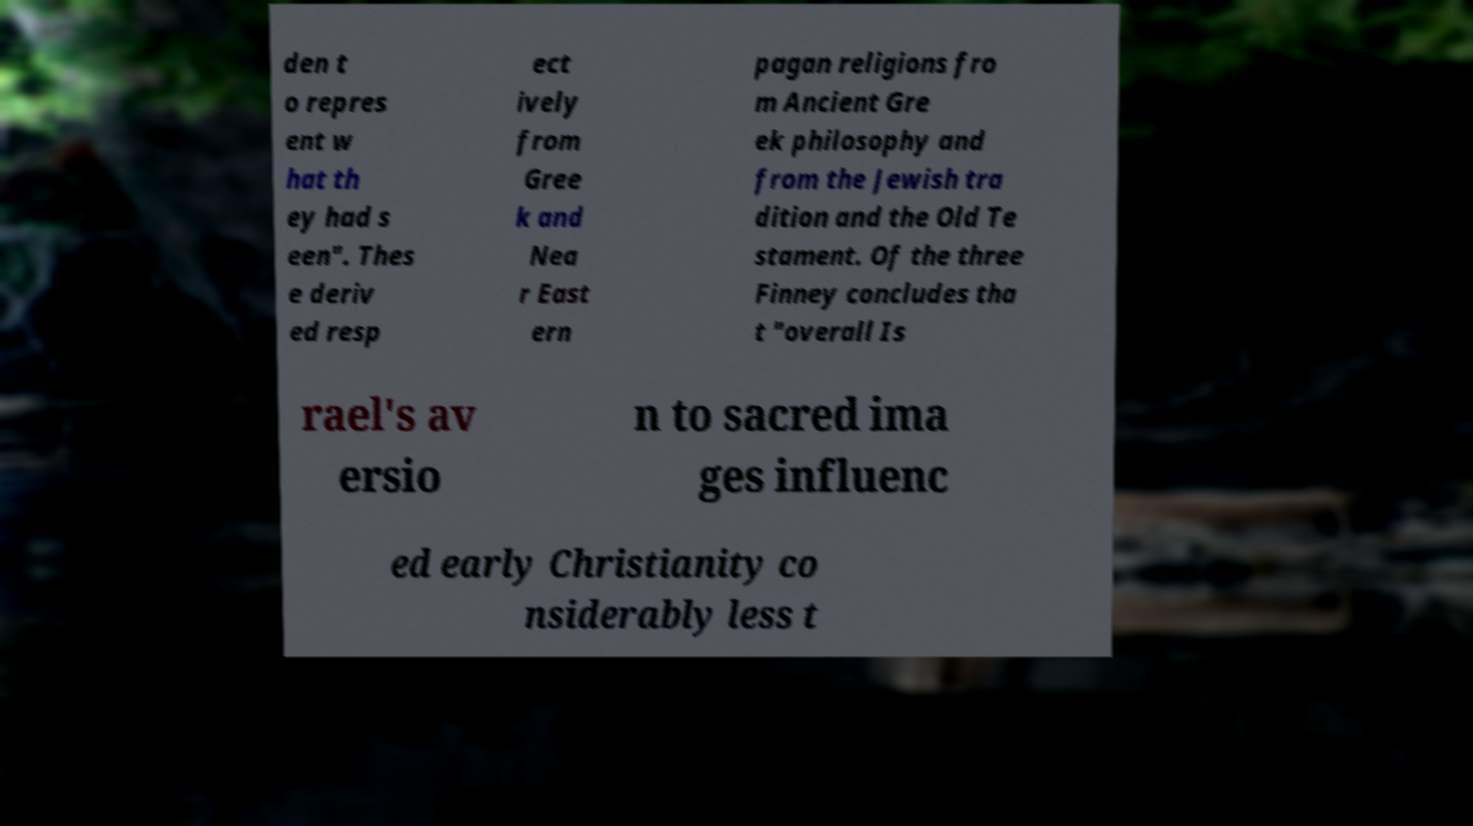For documentation purposes, I need the text within this image transcribed. Could you provide that? den t o repres ent w hat th ey had s een". Thes e deriv ed resp ect ively from Gree k and Nea r East ern pagan religions fro m Ancient Gre ek philosophy and from the Jewish tra dition and the Old Te stament. Of the three Finney concludes tha t "overall Is rael's av ersio n to sacred ima ges influenc ed early Christianity co nsiderably less t 